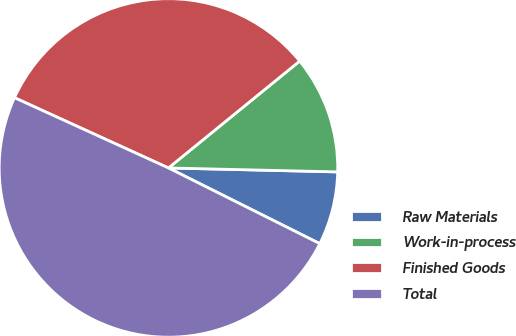Convert chart to OTSL. <chart><loc_0><loc_0><loc_500><loc_500><pie_chart><fcel>Raw Materials<fcel>Work-in-process<fcel>Finished Goods<fcel>Total<nl><fcel>7.01%<fcel>11.25%<fcel>32.31%<fcel>49.43%<nl></chart> 